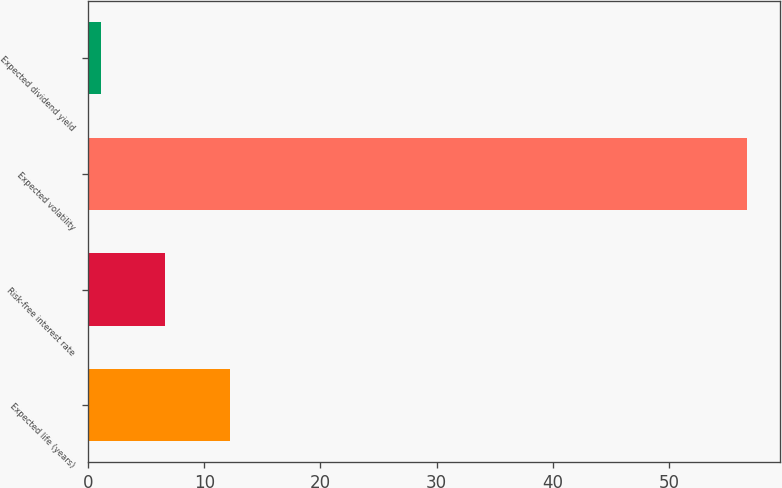Convert chart to OTSL. <chart><loc_0><loc_0><loc_500><loc_500><bar_chart><fcel>Expected life (years)<fcel>Risk-free interest rate<fcel>Expected volatility<fcel>Expected dividend yield<nl><fcel>12.22<fcel>6.66<fcel>56.7<fcel>1.1<nl></chart> 